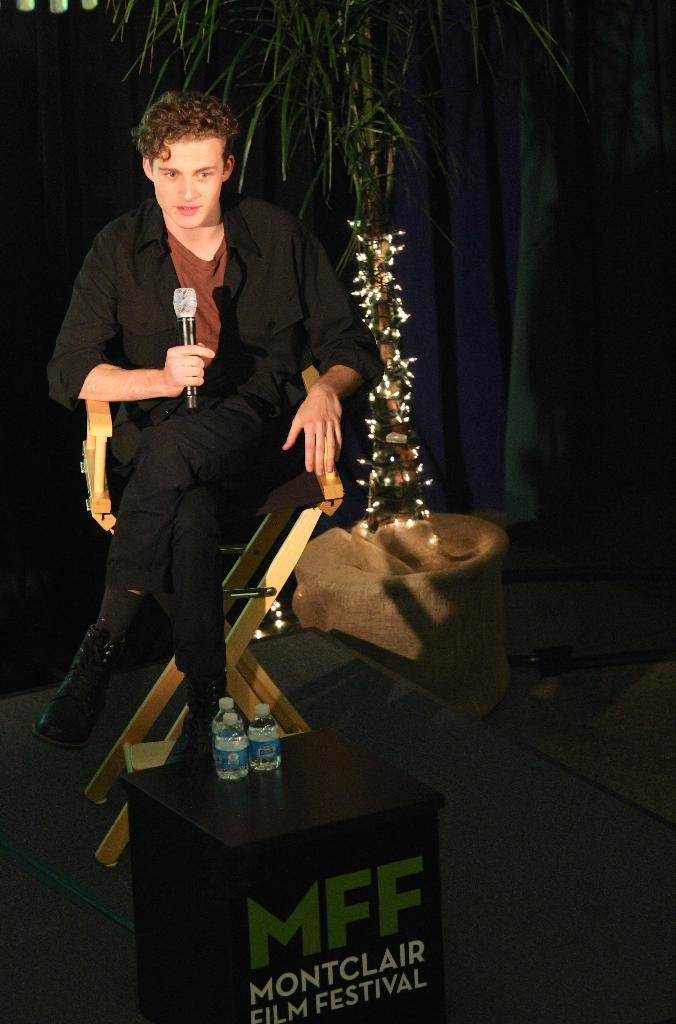Describe this image in one or two sentences. At the bottom of the image there is a table, on the table there are two bottles. Behind the table a person is sitting and holding a microphone. Behind him there is a plant. Behind the plant there is a cloth. 